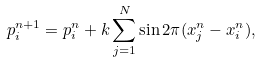Convert formula to latex. <formula><loc_0><loc_0><loc_500><loc_500>p ^ { n + 1 } _ { i } = p ^ { n } _ { i } + k \sum _ { j = 1 } ^ { N } \sin 2 \pi ( x ^ { n } _ { j } - x ^ { n } _ { i } ) ,</formula> 